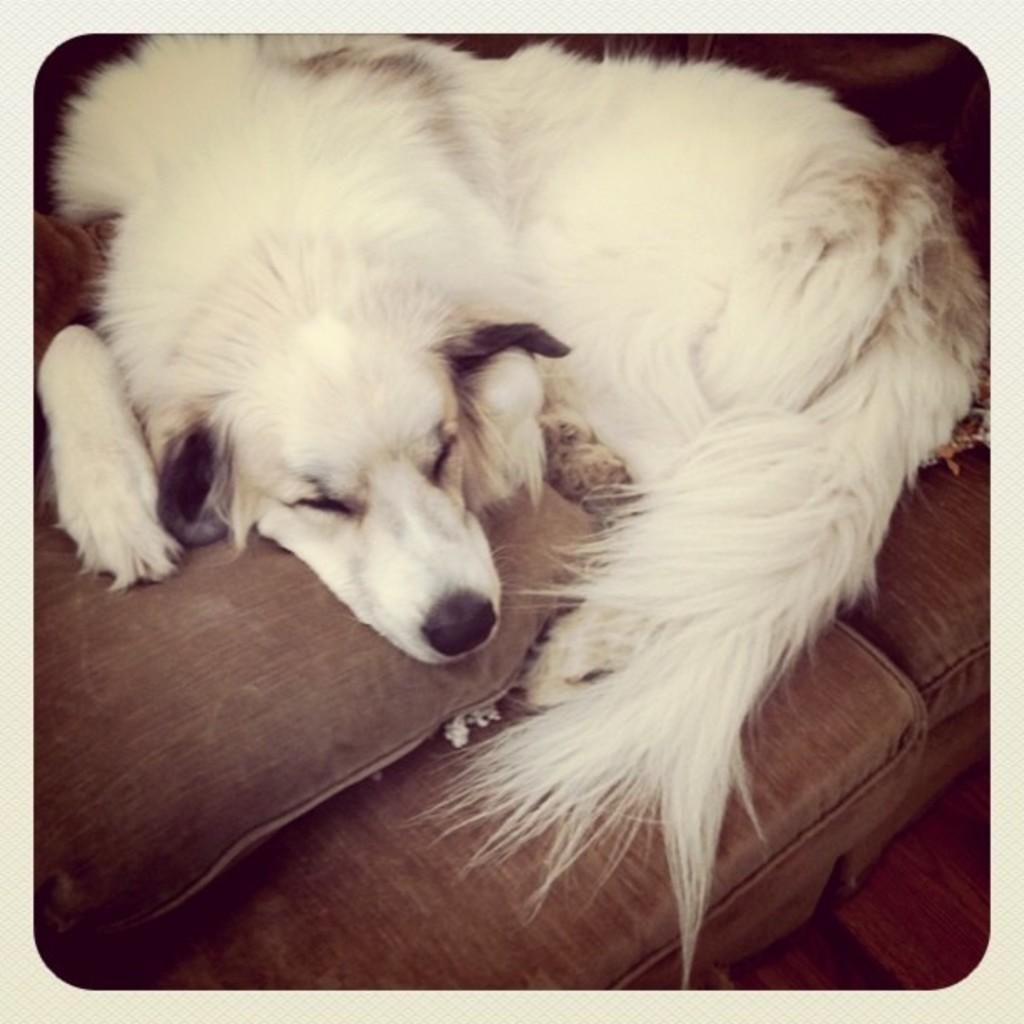How would you summarize this image in a sentence or two? In this image I see a dog which is of white in color and I see that it is on a couch which is of brown in color. 